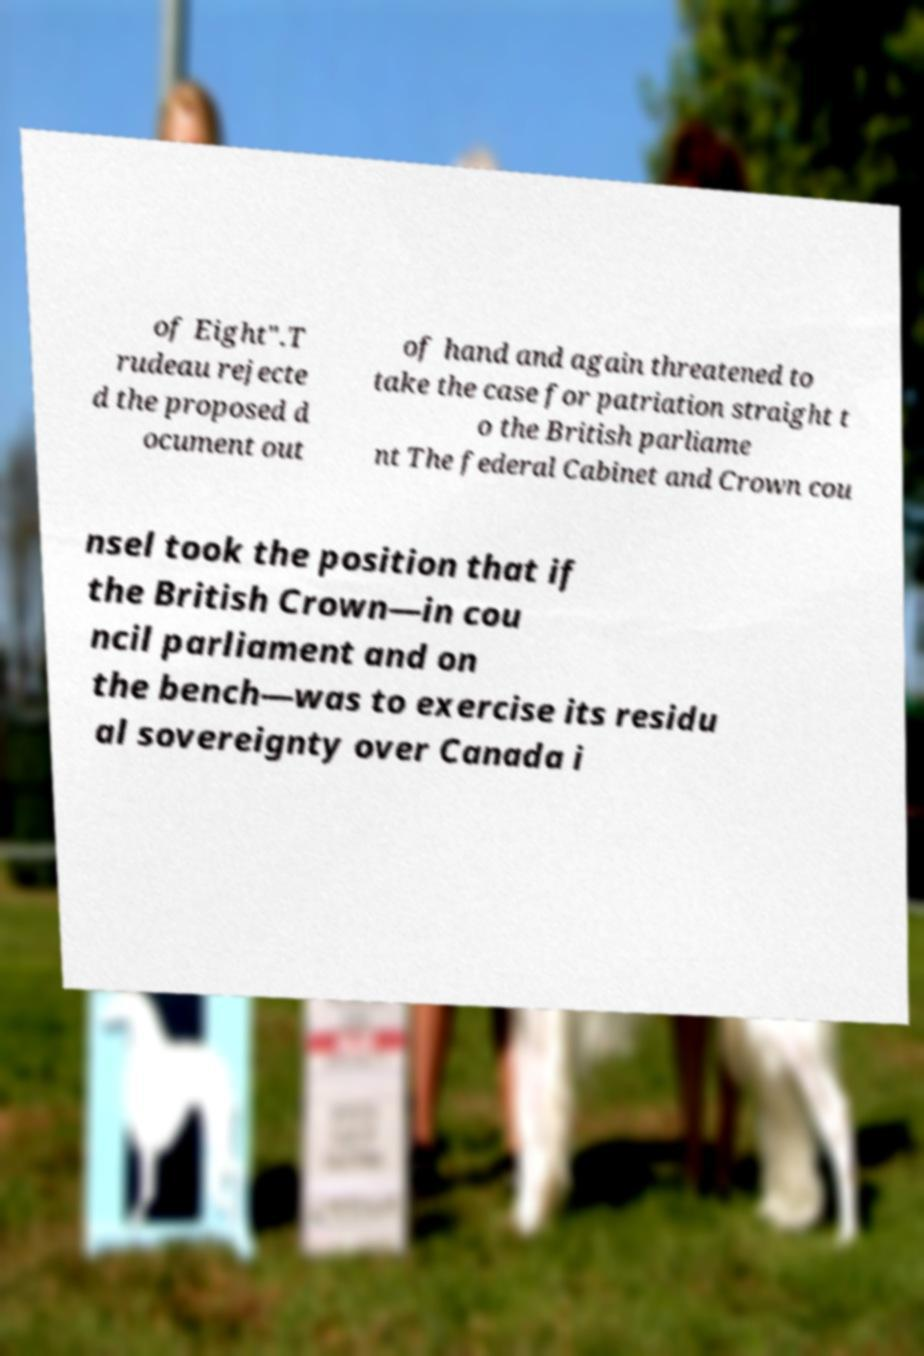Could you extract and type out the text from this image? of Eight".T rudeau rejecte d the proposed d ocument out of hand and again threatened to take the case for patriation straight t o the British parliame nt The federal Cabinet and Crown cou nsel took the position that if the British Crown—in cou ncil parliament and on the bench—was to exercise its residu al sovereignty over Canada i 